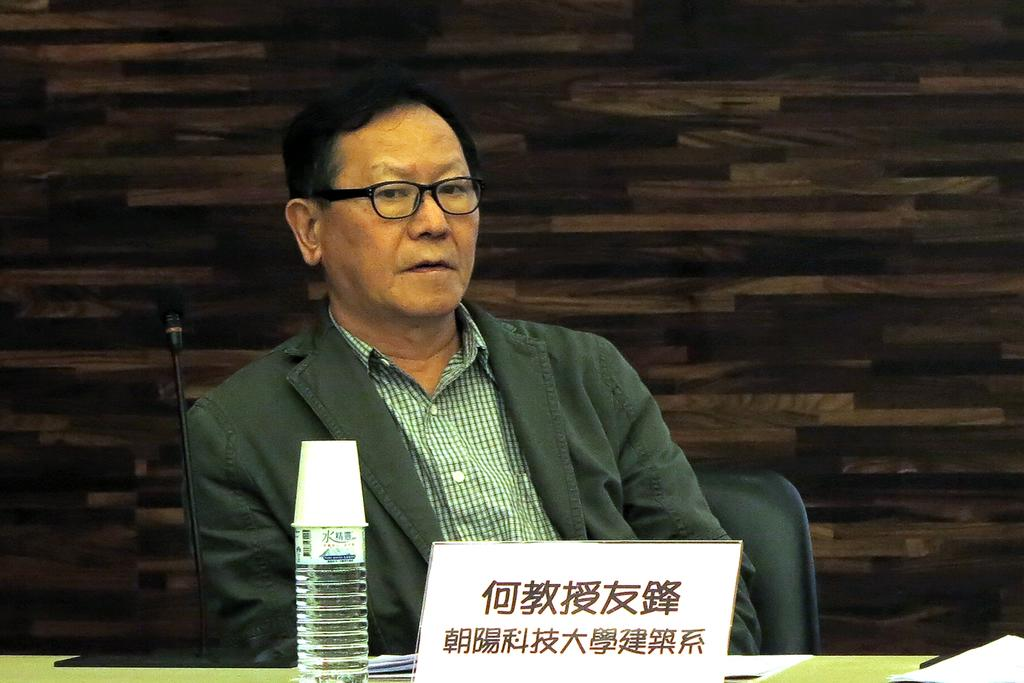Who is the main subject in the image? There is a man in the center of the image. What is in front of the man? There is a table in front of the man. What can be seen on the table? The table contains a name plate, a bottle, and a mic. How many cubs are playing with a brush on the table in the image? There are no cubs or brushes present on the table in the image. 